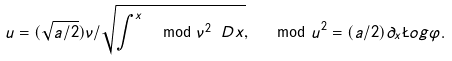<formula> <loc_0><loc_0><loc_500><loc_500>u = ( \sqrt { a / 2 } ) \nu / \sqrt { \int ^ { x } \mod { \nu } ^ { 2 } \ D x } , \ \mod { u } ^ { 2 } = ( a / 2 ) \partial _ { x } \L o g \varphi .</formula> 